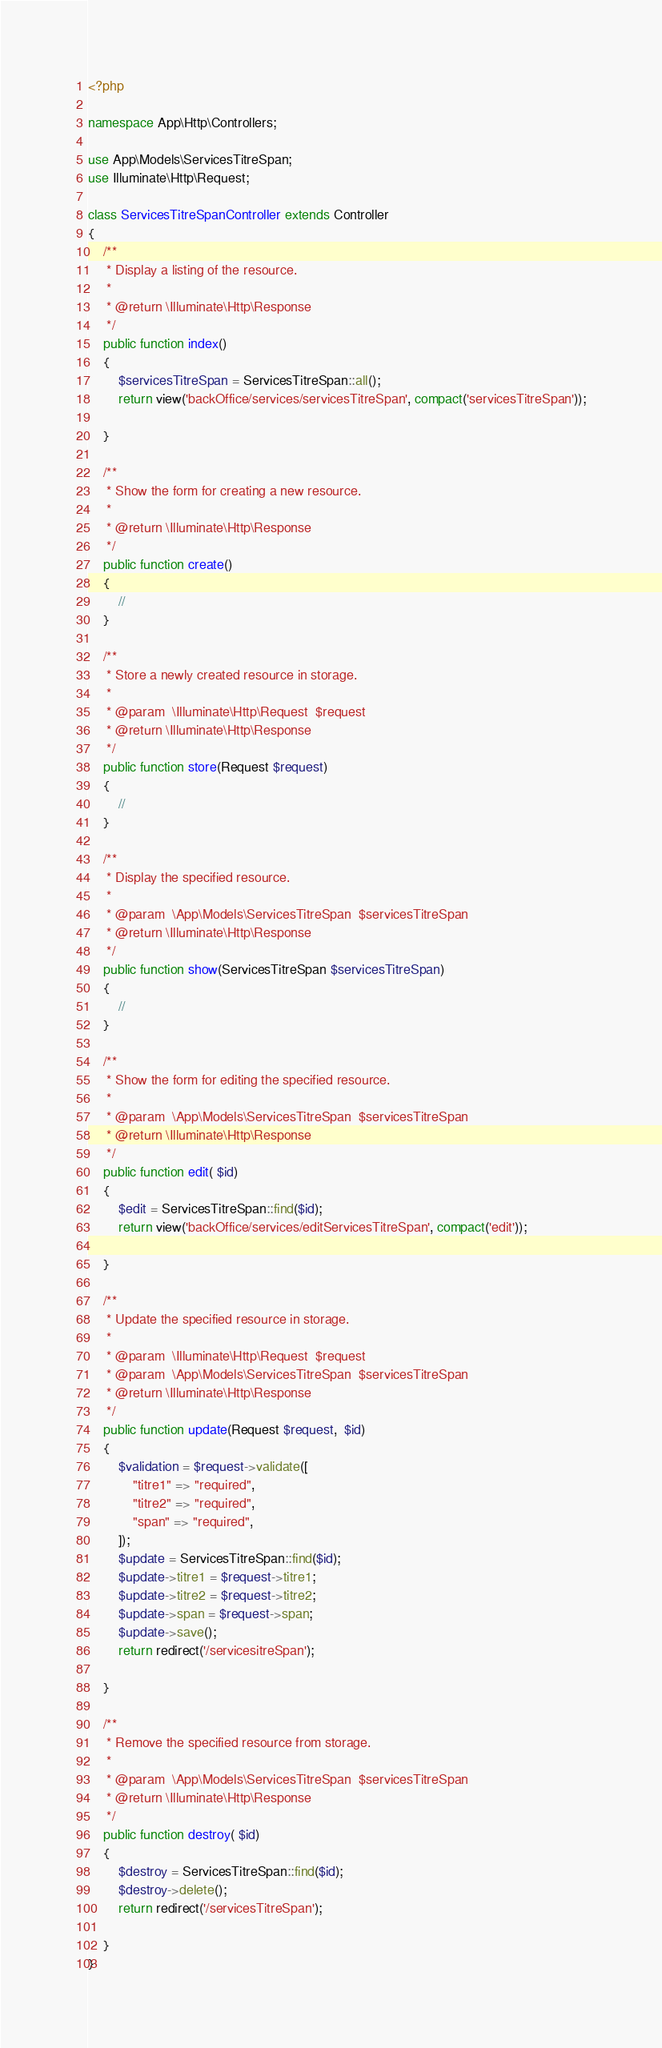<code> <loc_0><loc_0><loc_500><loc_500><_PHP_><?php

namespace App\Http\Controllers;

use App\Models\ServicesTitreSpan;
use Illuminate\Http\Request;

class ServicesTitreSpanController extends Controller
{
    /**
     * Display a listing of the resource.
     *
     * @return \Illuminate\Http\Response
     */
    public function index()
    {
        $servicesTitreSpan = ServicesTitreSpan::all();
        return view('backOffice/services/servicesTitreSpan', compact('servicesTitreSpan'));

    }

    /**
     * Show the form for creating a new resource.
     *
     * @return \Illuminate\Http\Response
     */
    public function create()
    {
        //
    }

    /**
     * Store a newly created resource in storage.
     *
     * @param  \Illuminate\Http\Request  $request
     * @return \Illuminate\Http\Response
     */
    public function store(Request $request)
    {
        //
    }

    /**
     * Display the specified resource.
     *
     * @param  \App\Models\ServicesTitreSpan  $servicesTitreSpan
     * @return \Illuminate\Http\Response
     */
    public function show(ServicesTitreSpan $servicesTitreSpan)
    {
        //
    }

    /**
     * Show the form for editing the specified resource.
     *
     * @param  \App\Models\ServicesTitreSpan  $servicesTitreSpan
     * @return \Illuminate\Http\Response
     */
    public function edit( $id)
    {
        $edit = ServicesTitreSpan::find($id);
        return view('backOffice/services/editServicesTitreSpan', compact('edit'));

    }

    /**
     * Update the specified resource in storage.
     *
     * @param  \Illuminate\Http\Request  $request
     * @param  \App\Models\ServicesTitreSpan  $servicesTitreSpan
     * @return \Illuminate\Http\Response
     */
    public function update(Request $request,  $id)
    {
        $validation = $request->validate([
            "titre1" => "required",
            "titre2" => "required",
            "span" => "required",
        ]);
        $update = ServicesTitreSpan::find($id);
        $update->titre1 = $request->titre1;
        $update->titre2 = $request->titre2;
        $update->span = $request->span;
        $update->save();
        return redirect('/servicesitreSpan');

    }

    /**
     * Remove the specified resource from storage.
     *
     * @param  \App\Models\ServicesTitreSpan  $servicesTitreSpan
     * @return \Illuminate\Http\Response
     */
    public function destroy( $id)
    {
        $destroy = ServicesTitreSpan::find($id);
        $destroy->delete();
        return redirect('/servicesTitreSpan');

    }
}
</code> 